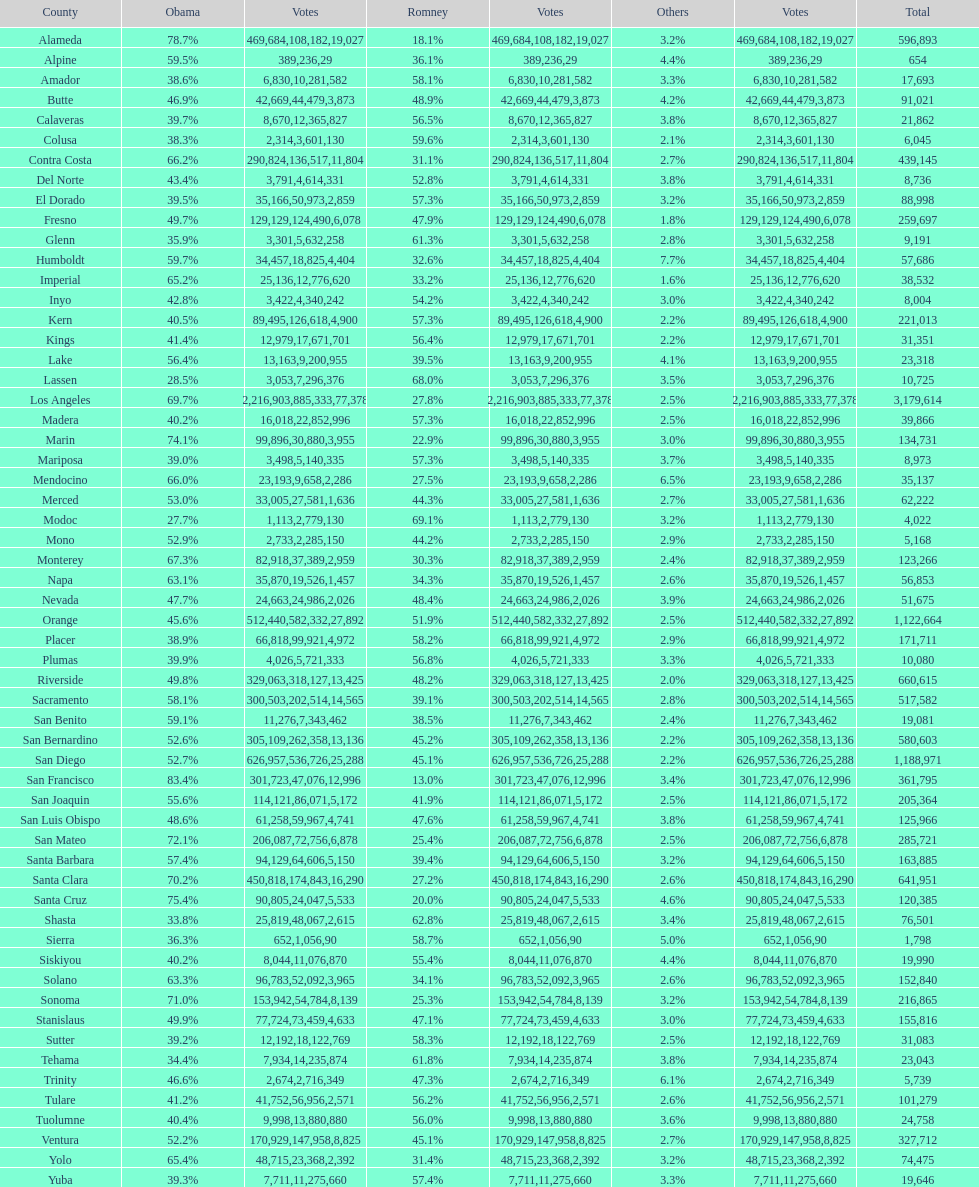What is the complete tally of votes for amador? 17693. 